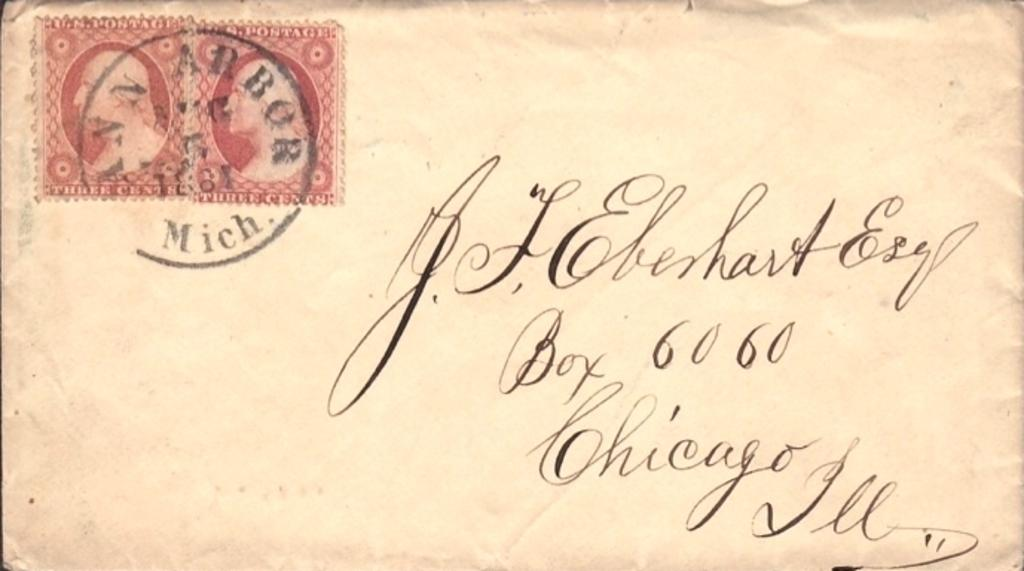<image>
Relay a brief, clear account of the picture shown. An old letter with two stamps shipped from Michigan to Chicago. 